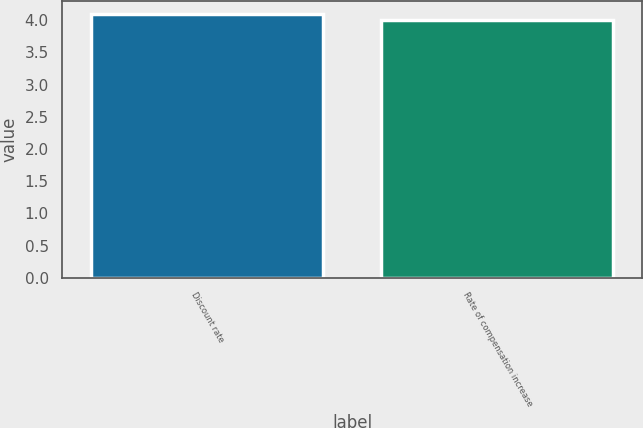Convert chart to OTSL. <chart><loc_0><loc_0><loc_500><loc_500><bar_chart><fcel>Discount rate<fcel>Rate of compensation increase<nl><fcel>4.1<fcel>4<nl></chart> 